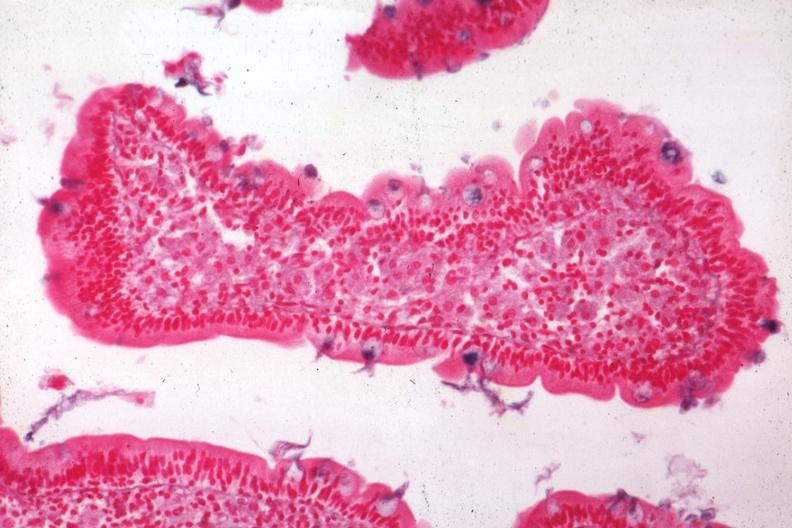s whipples disease present?
Answer the question using a single word or phrase. Yes 